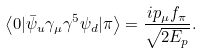Convert formula to latex. <formula><loc_0><loc_0><loc_500><loc_500>\left < 0 | \bar { \psi } _ { u } \gamma _ { \mu } \gamma ^ { 5 } \psi _ { d } | \pi \right > = \frac { i p _ { \mu } f _ { \pi } } { \sqrt { 2 E _ { p } } } .</formula> 